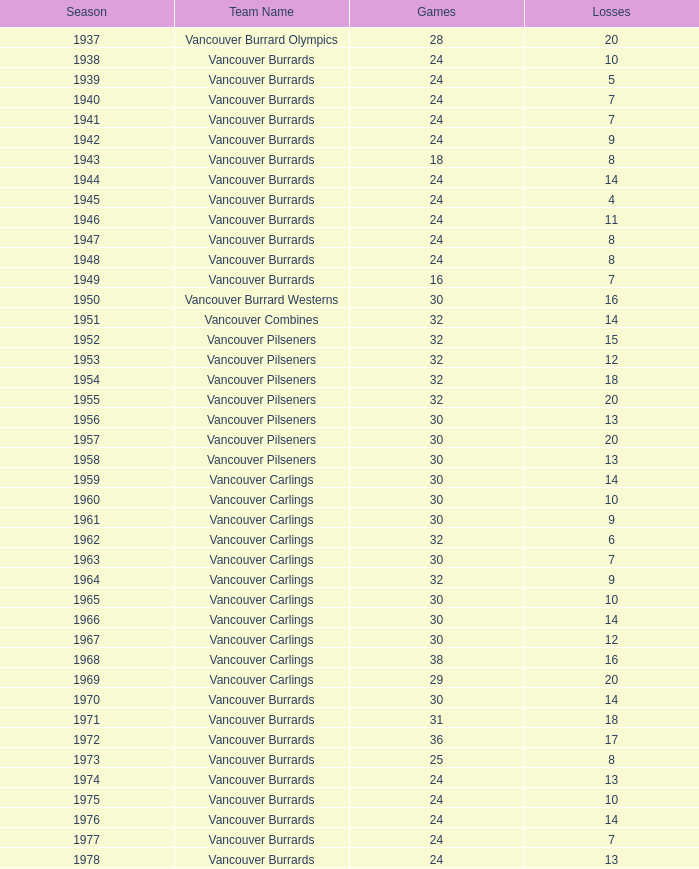How many total points do the vancouver burrards accumulate when their losses are fewer than 9 and their games played exceed 24? 1.0. 